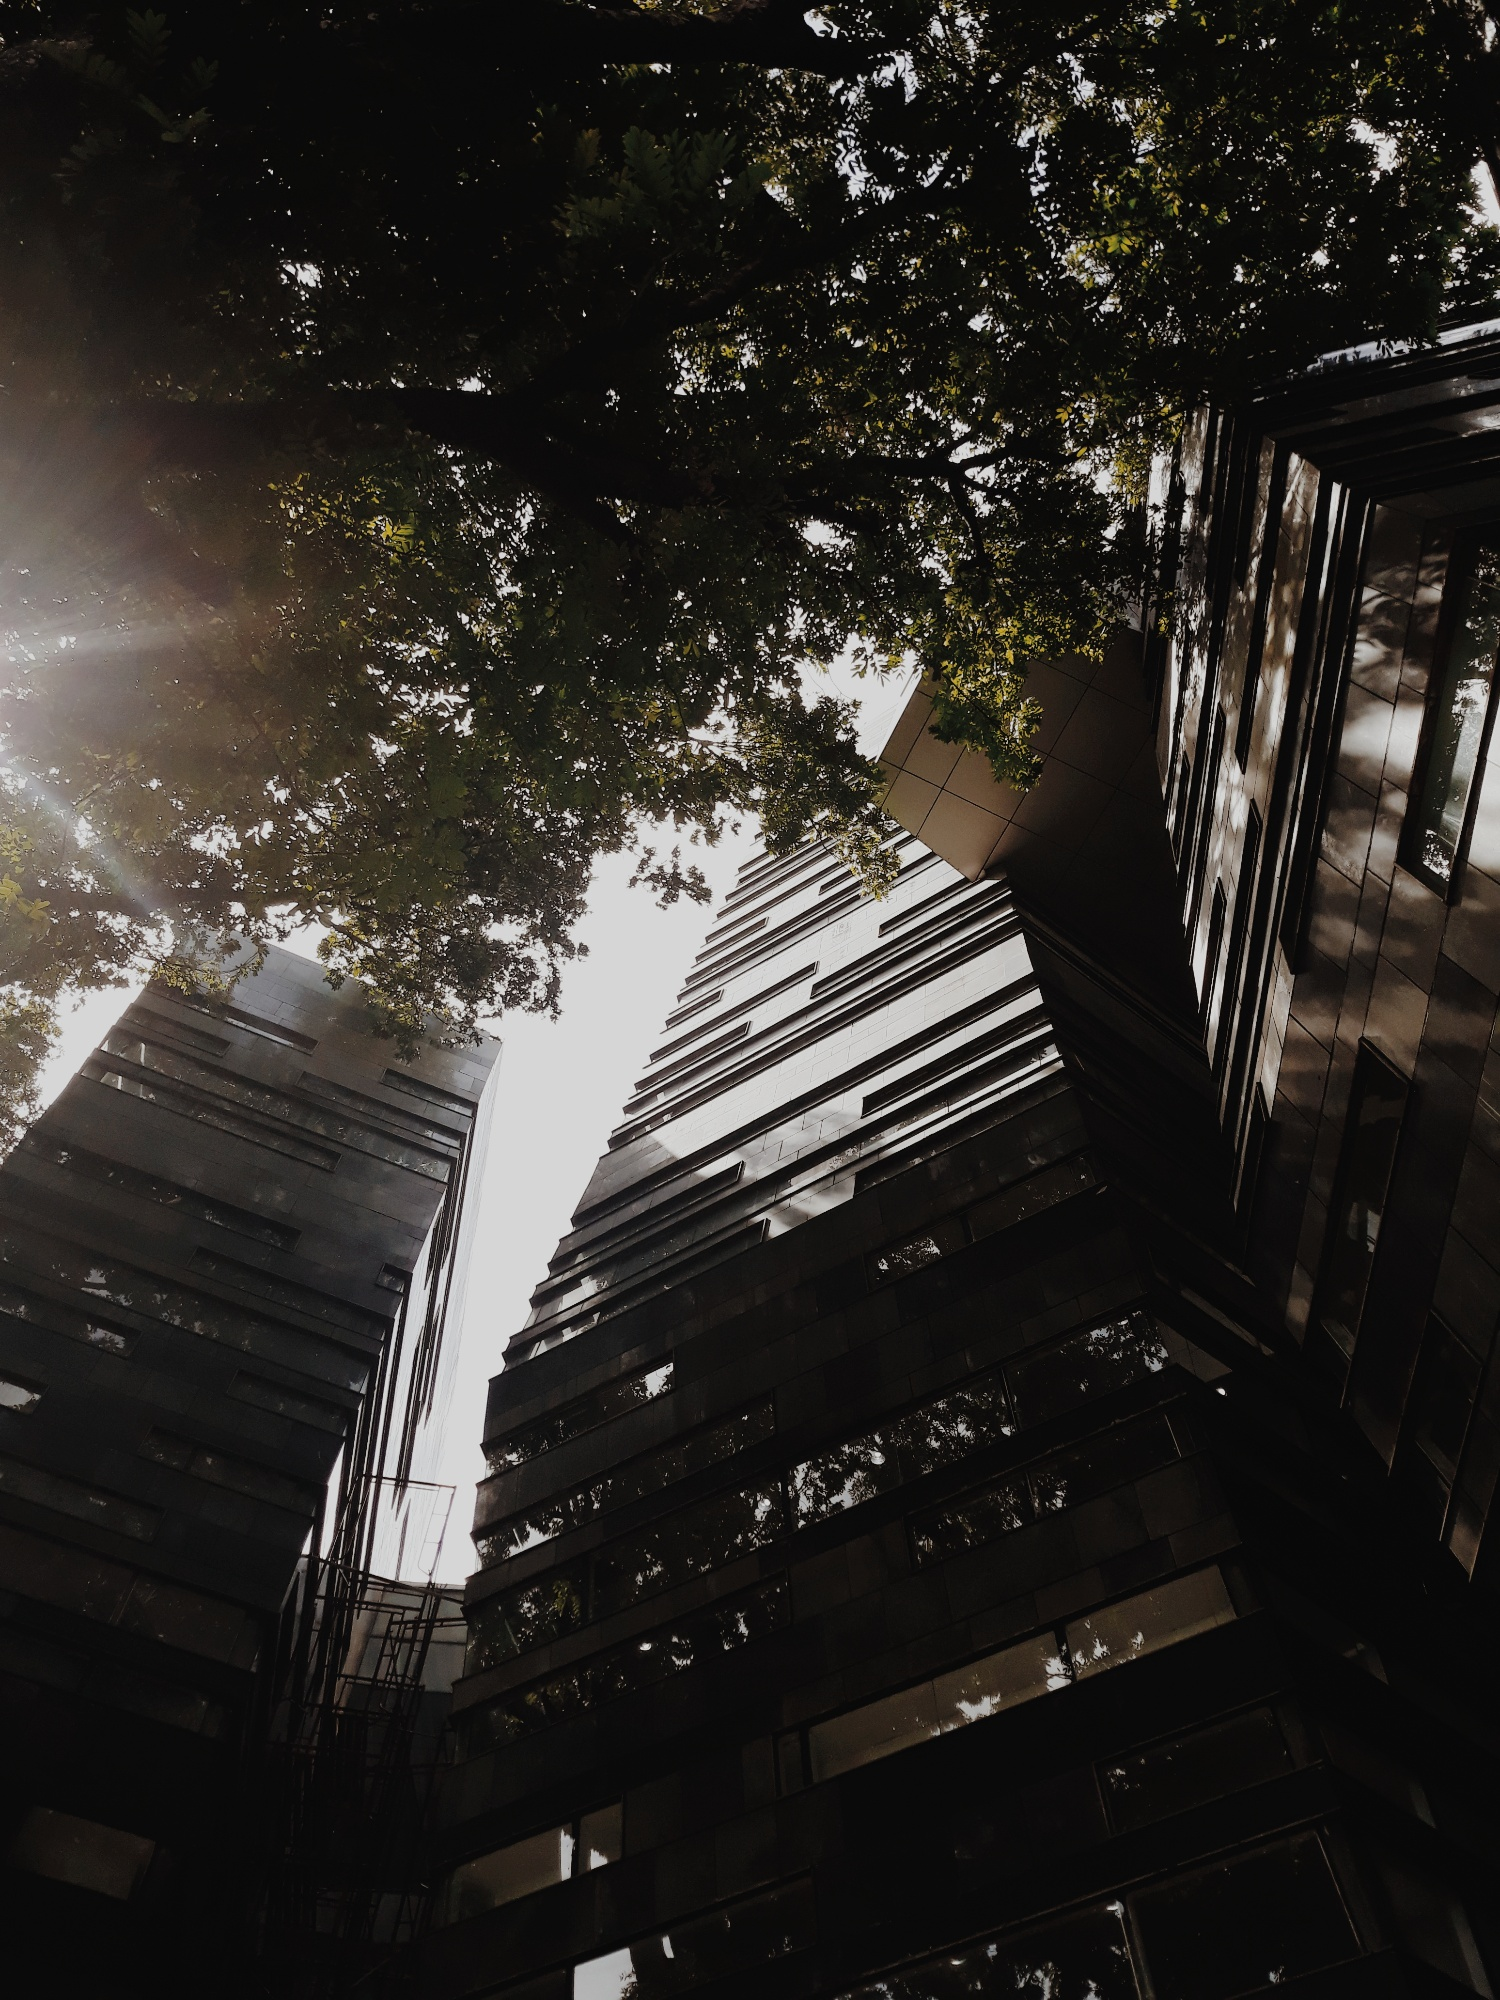Explain the visual content of the image in great detail. The image portrays a striking modern building, towering amidst a grove of trees under a sunlit sky. Viewed from a low vantage point, the structure is composed of reflective glass and prominent steel layers, which form a rhythmic, zigzag pattern along its facade. The design is dynamic, with each layer slightly offset from the one below, adding a sense of vertical movement and architectural interest. The surrounding foliage frames the building, introducing natural green hues that contrast with the building's metallic and glass materials. The image conveys not only the physical characteristics of the building but also the interaction between nature and modern urban constructions, emphasizing a blend of natural beauty with human innovation. 